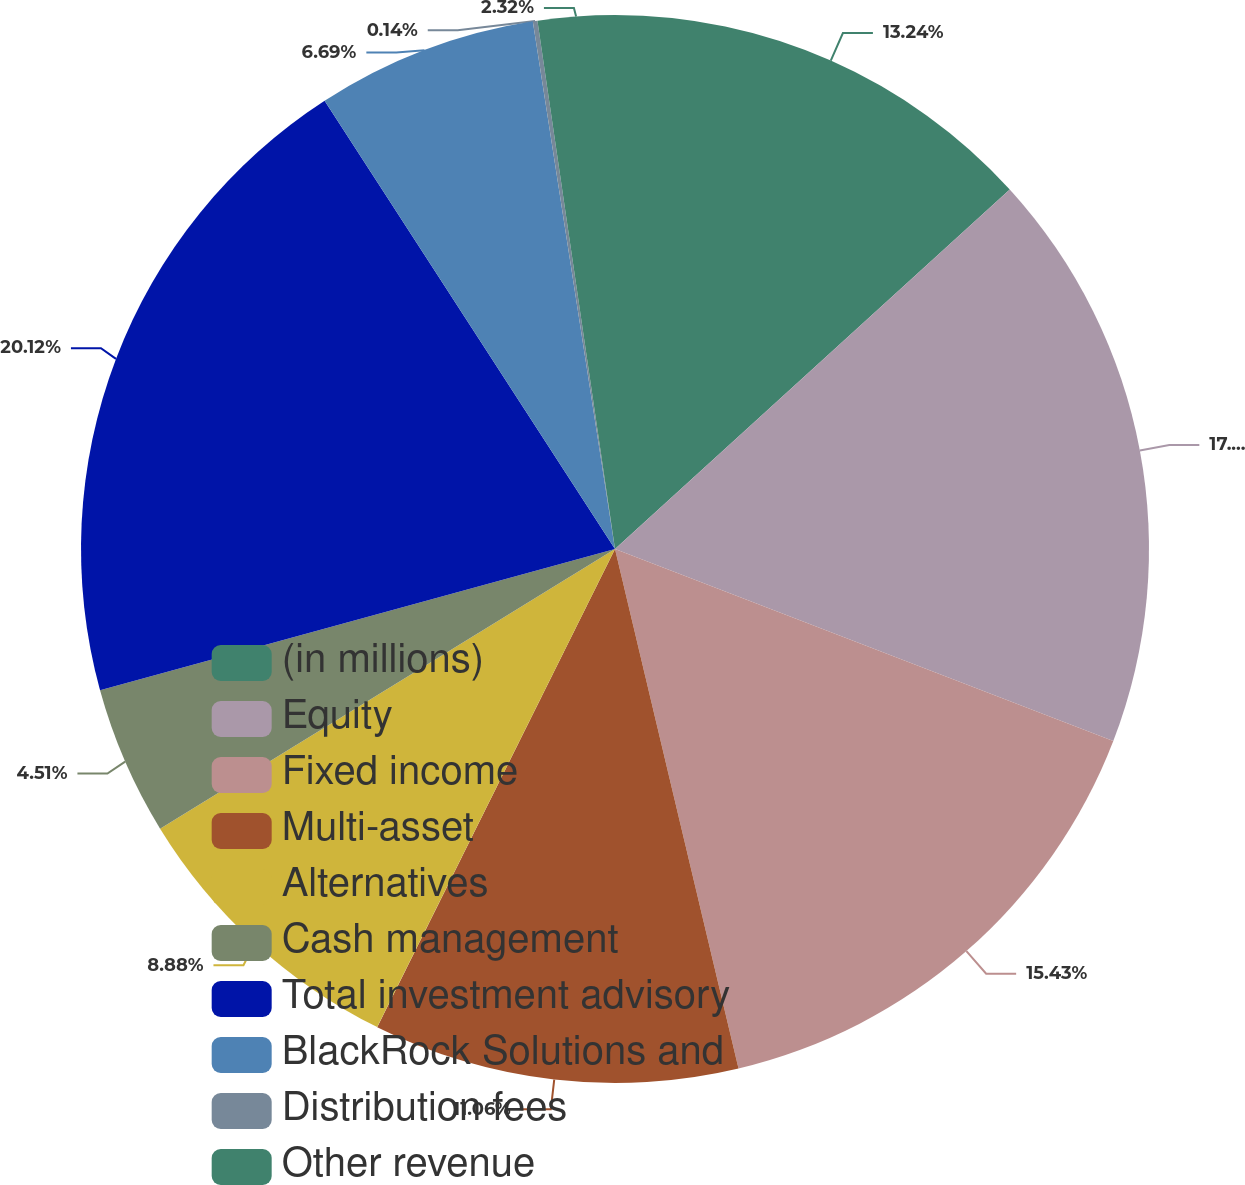<chart> <loc_0><loc_0><loc_500><loc_500><pie_chart><fcel>(in millions)<fcel>Equity<fcel>Fixed income<fcel>Multi-asset<fcel>Alternatives<fcel>Cash management<fcel>Total investment advisory<fcel>BlackRock Solutions and<fcel>Distribution fees<fcel>Other revenue<nl><fcel>13.24%<fcel>17.61%<fcel>15.43%<fcel>11.06%<fcel>8.88%<fcel>4.51%<fcel>20.11%<fcel>6.69%<fcel>0.14%<fcel>2.32%<nl></chart> 